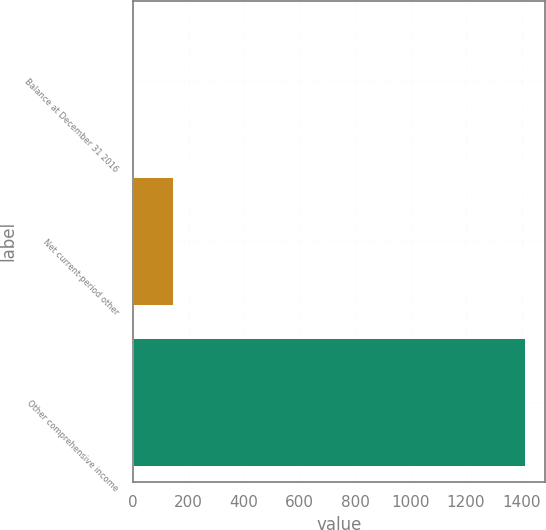Convert chart. <chart><loc_0><loc_0><loc_500><loc_500><bar_chart><fcel>Balance at December 31 2016<fcel>Net current-period other<fcel>Other comprehensive income<nl><fcel>2<fcel>143.2<fcel>1414<nl></chart> 